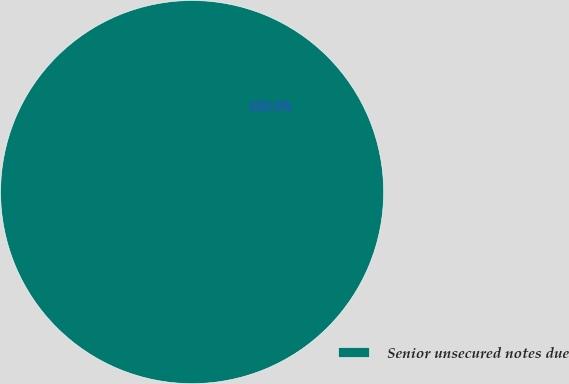Convert chart to OTSL. <chart><loc_0><loc_0><loc_500><loc_500><pie_chart><fcel>Senior unsecured notes due<nl><fcel>100.0%<nl></chart> 